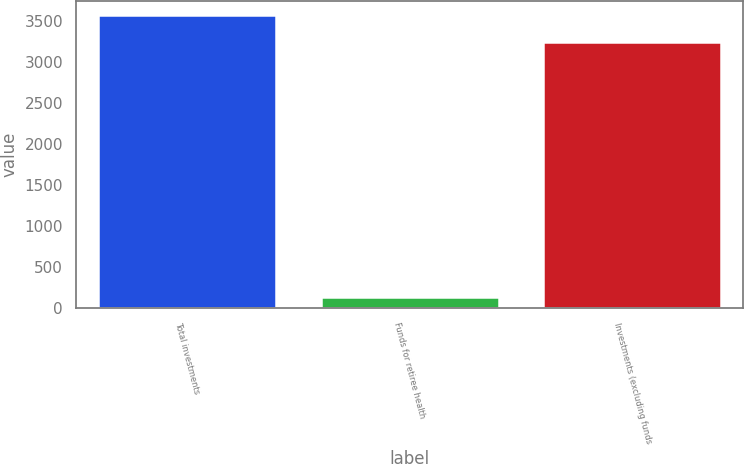<chart> <loc_0><loc_0><loc_500><loc_500><bar_chart><fcel>Total investments<fcel>Funds for retiree health<fcel>Investments (excluding funds<nl><fcel>3576.1<fcel>134<fcel>3251<nl></chart> 